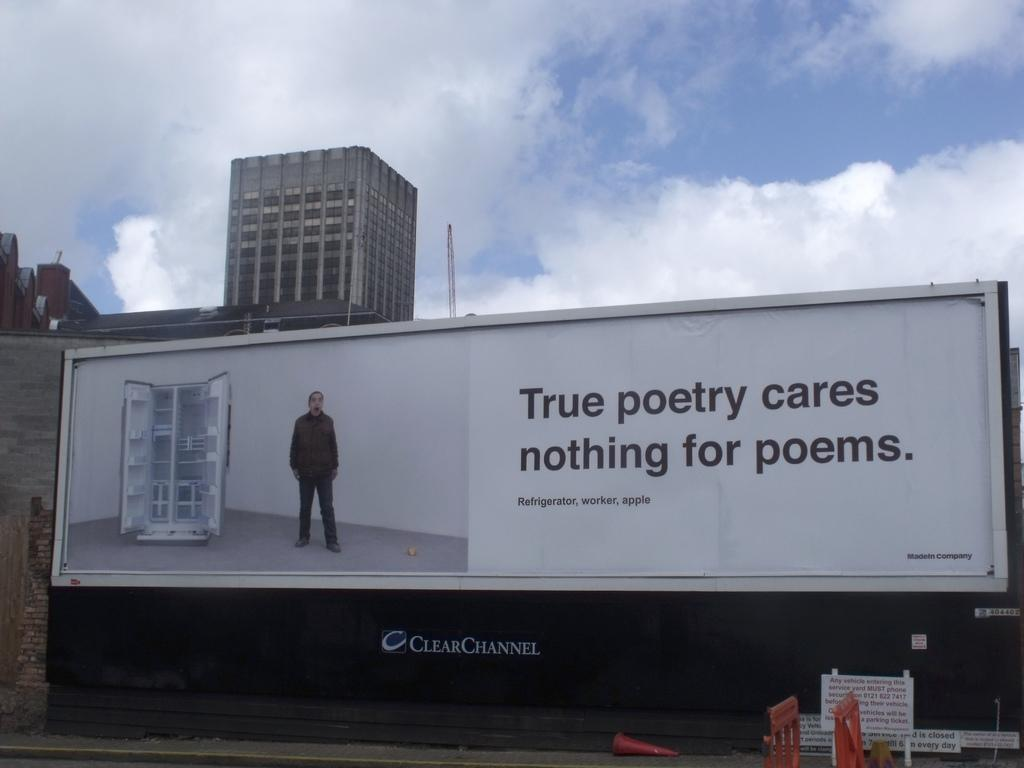<image>
Relay a brief, clear account of the picture shown. a billboard that says 'true poetry cares nothing for poems.' 